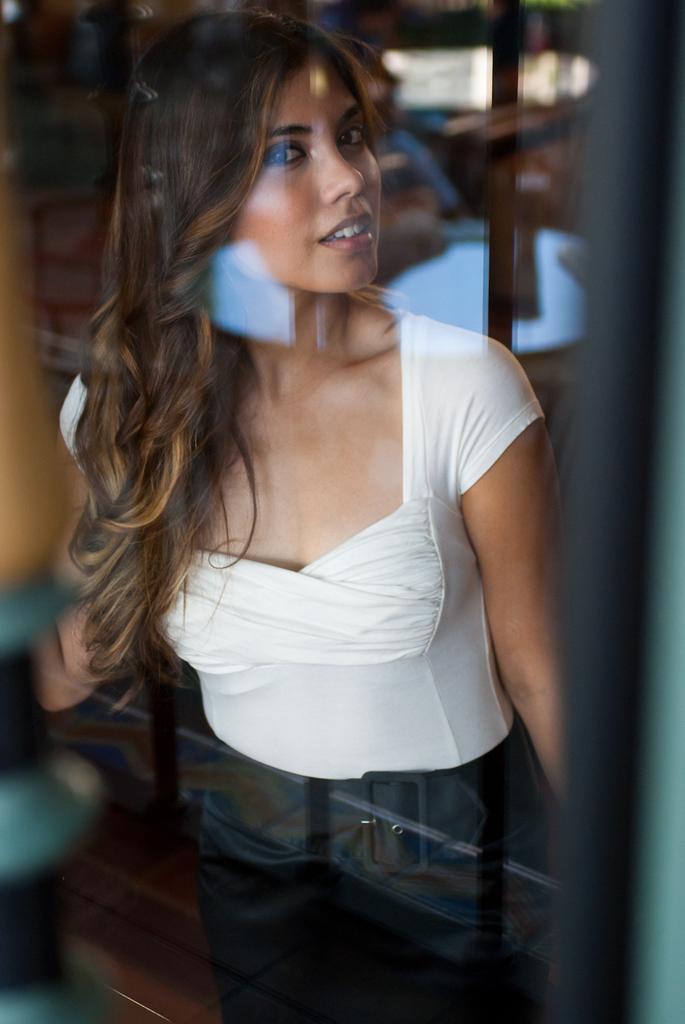In one or two sentences, can you explain what this image depicts? I think this is the glass with a reflection. Here is the woman standing and smiling. She wore a white top and trouser. 